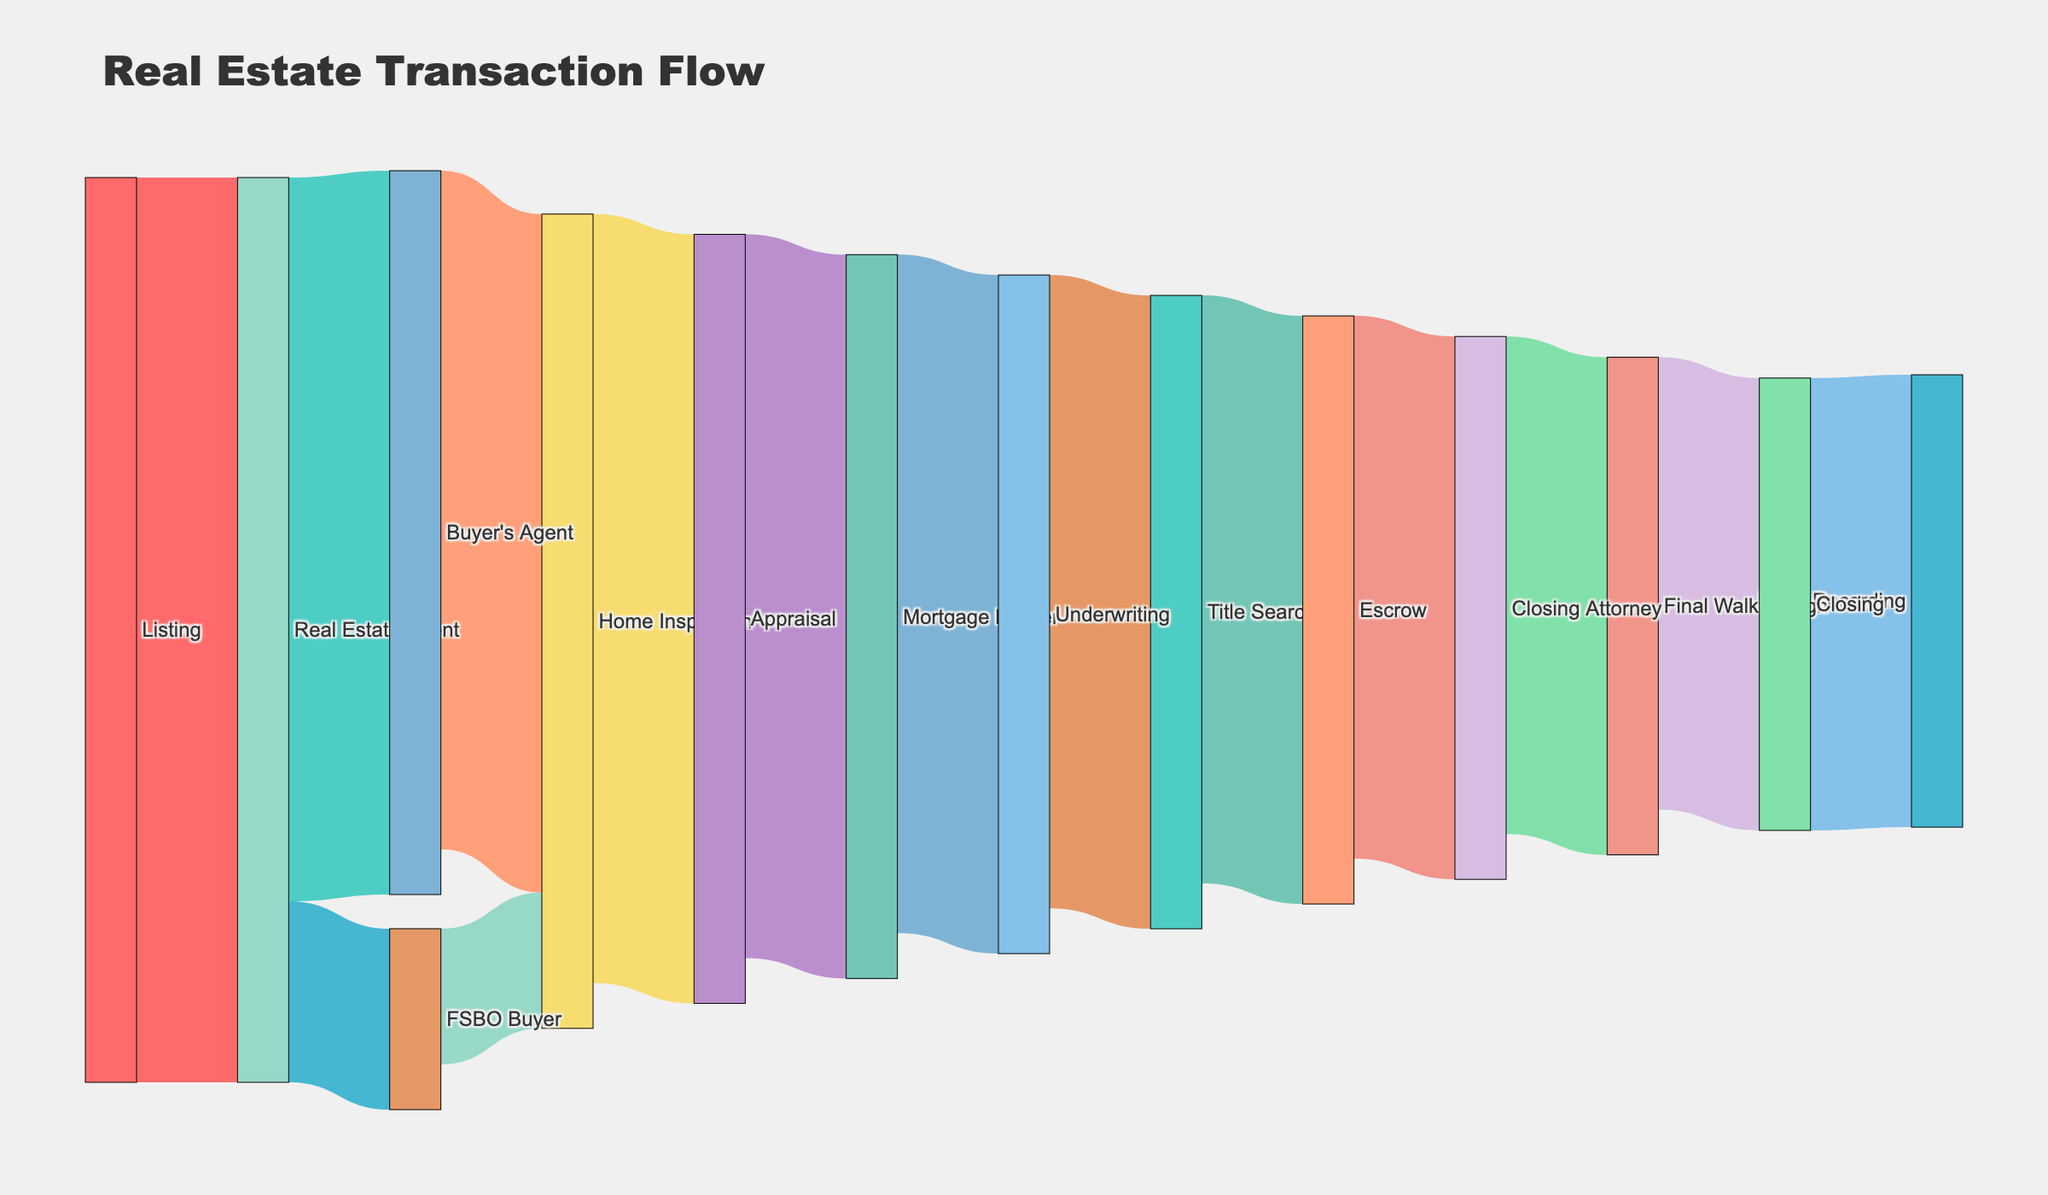How many stages are involved in the real estate transaction flow? First, identify all unique elements from both source and target columns. Then count the total number of listed stages. There are 14 unique stages.
Answer: 14 What is the primary intermediary after the listing of a real estate property? Check the target column associated with the highest value (100) coming from the Listing source. The immediate intermediary is the "Real Estate Agent".
Answer: Real Estate Agent How does the flow split after the Real Estate Agent handles the listing? The sources connected to the Real Estate Agent split into “Buyer’s Agent” with a value of 80 and “FSBO Buyer” with a value of 20.
Answer: Buyer’s Agent and FSBO Buyer What is the final stage in the real estate transaction flow? Trace the flow to the last target column, where "Deed Recording" is stated as the final stage.
Answer: Deed Recording What percentage of the transactions go through the Buyer's Agent pathway? From the Real Estate Agent value (100), the Buyer's Agent pathway has a value of 80. The percentage is (80/100) * 100% = 80%.
Answer: 80% Compare the number of transactions going through Home Inspection from Buyer's Agent versus FSBO Buyer. Identify the associated values: Buyer's Agent to Home Inspection is 75, FSBO Buyer to Home Inspection is 15. The difference is 75 - 15 = 60.
Answer: 60 Which processes involve the Mortgage Lender, and what are their flow values? Look for processes that lead to Mortgage Lender and their subsequent stages. Home Inspection to Appraisal is 85, and Appraisal to Mortgage Lender is 80.
Answer: Appraisal: 80 Determine the total number of transactions that reach the Closing stage. Trace all preceding stages leading to Closing and sum their values. Final Walkthrough flows to Closing with a value of 50, indicating 50 reach this stage.
Answer: 50 During which stage is the highest decrease in the number of transactions observed? Compare the decrease in values between consecutive stages. Real Estate Agent to Buyer’s Agent and FSBO Buyer to Home Inspection shows a drop of 25 (80 to 75).
Answer: Home Inspection to Appraisal 